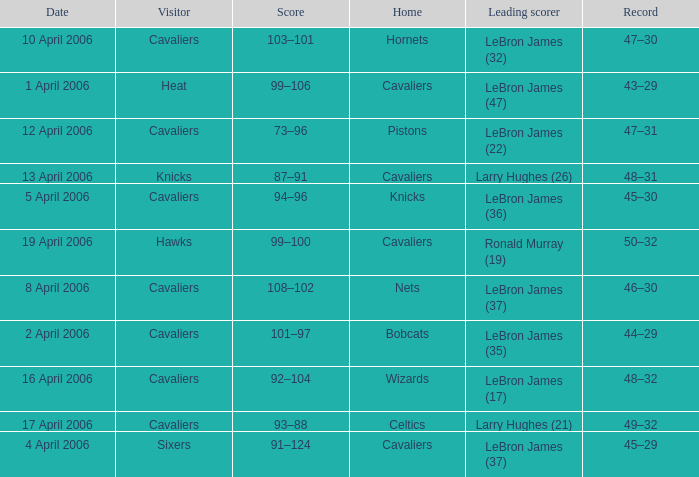What day was the game that had the Cavaliers as visiting team and the Knicks as the home team? 5 April 2006. 